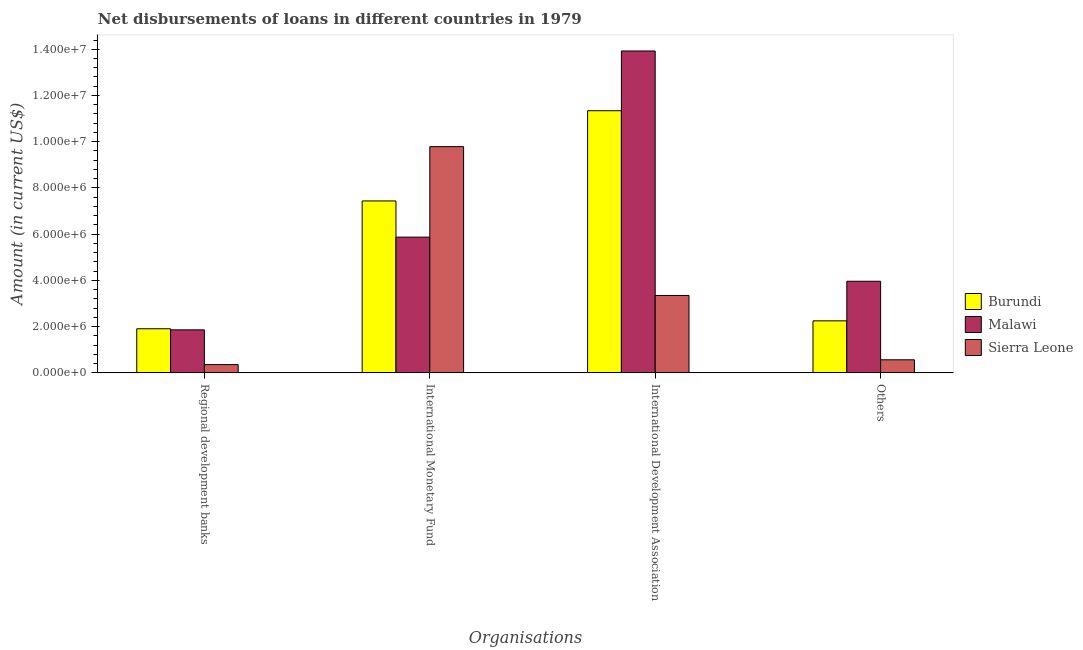How many groups of bars are there?
Provide a short and direct response. 4. What is the label of the 4th group of bars from the left?
Ensure brevity in your answer.  Others. What is the amount of loan disimbursed by regional development banks in Sierra Leone?
Your response must be concise. 3.57e+05. Across all countries, what is the maximum amount of loan disimbursed by international monetary fund?
Ensure brevity in your answer.  9.79e+06. Across all countries, what is the minimum amount of loan disimbursed by regional development banks?
Make the answer very short. 3.57e+05. In which country was the amount of loan disimbursed by regional development banks maximum?
Provide a short and direct response. Burundi. In which country was the amount of loan disimbursed by international monetary fund minimum?
Provide a succinct answer. Malawi. What is the total amount of loan disimbursed by other organisations in the graph?
Provide a short and direct response. 6.78e+06. What is the difference between the amount of loan disimbursed by regional development banks in Burundi and that in Sierra Leone?
Your response must be concise. 1.55e+06. What is the difference between the amount of loan disimbursed by international development association in Burundi and the amount of loan disimbursed by regional development banks in Malawi?
Offer a terse response. 9.48e+06. What is the average amount of loan disimbursed by other organisations per country?
Keep it short and to the point. 2.26e+06. What is the difference between the amount of loan disimbursed by international development association and amount of loan disimbursed by international monetary fund in Sierra Leone?
Offer a terse response. -6.44e+06. In how many countries, is the amount of loan disimbursed by regional development banks greater than 6400000 US$?
Ensure brevity in your answer.  0. What is the ratio of the amount of loan disimbursed by other organisations in Sierra Leone to that in Burundi?
Offer a very short reply. 0.25. What is the difference between the highest and the second highest amount of loan disimbursed by regional development banks?
Make the answer very short. 4.70e+04. What is the difference between the highest and the lowest amount of loan disimbursed by international development association?
Offer a very short reply. 1.06e+07. Is it the case that in every country, the sum of the amount of loan disimbursed by international monetary fund and amount of loan disimbursed by international development association is greater than the sum of amount of loan disimbursed by other organisations and amount of loan disimbursed by regional development banks?
Your answer should be very brief. Yes. What does the 3rd bar from the left in Others represents?
Provide a short and direct response. Sierra Leone. What does the 1st bar from the right in Others represents?
Offer a terse response. Sierra Leone. Is it the case that in every country, the sum of the amount of loan disimbursed by regional development banks and amount of loan disimbursed by international monetary fund is greater than the amount of loan disimbursed by international development association?
Keep it short and to the point. No. How many bars are there?
Ensure brevity in your answer.  12. Are all the bars in the graph horizontal?
Keep it short and to the point. No. How many countries are there in the graph?
Make the answer very short. 3. What is the difference between two consecutive major ticks on the Y-axis?
Your answer should be compact. 2.00e+06. Does the graph contain any zero values?
Offer a very short reply. No. Does the graph contain grids?
Offer a terse response. No. How many legend labels are there?
Give a very brief answer. 3. What is the title of the graph?
Your answer should be compact. Net disbursements of loans in different countries in 1979. Does "Bahrain" appear as one of the legend labels in the graph?
Provide a succinct answer. No. What is the label or title of the X-axis?
Your answer should be compact. Organisations. What is the Amount (in current US$) in Burundi in Regional development banks?
Your answer should be compact. 1.91e+06. What is the Amount (in current US$) in Malawi in Regional development banks?
Give a very brief answer. 1.86e+06. What is the Amount (in current US$) of Sierra Leone in Regional development banks?
Your answer should be very brief. 3.57e+05. What is the Amount (in current US$) in Burundi in International Monetary Fund?
Your answer should be very brief. 7.44e+06. What is the Amount (in current US$) of Malawi in International Monetary Fund?
Provide a succinct answer. 5.87e+06. What is the Amount (in current US$) of Sierra Leone in International Monetary Fund?
Keep it short and to the point. 9.79e+06. What is the Amount (in current US$) of Burundi in International Development Association?
Provide a short and direct response. 1.13e+07. What is the Amount (in current US$) in Malawi in International Development Association?
Make the answer very short. 1.39e+07. What is the Amount (in current US$) of Sierra Leone in International Development Association?
Ensure brevity in your answer.  3.35e+06. What is the Amount (in current US$) in Burundi in Others?
Give a very brief answer. 2.25e+06. What is the Amount (in current US$) in Malawi in Others?
Make the answer very short. 3.96e+06. What is the Amount (in current US$) of Sierra Leone in Others?
Provide a succinct answer. 5.66e+05. Across all Organisations, what is the maximum Amount (in current US$) in Burundi?
Provide a succinct answer. 1.13e+07. Across all Organisations, what is the maximum Amount (in current US$) in Malawi?
Your answer should be compact. 1.39e+07. Across all Organisations, what is the maximum Amount (in current US$) in Sierra Leone?
Make the answer very short. 9.79e+06. Across all Organisations, what is the minimum Amount (in current US$) of Burundi?
Give a very brief answer. 1.91e+06. Across all Organisations, what is the minimum Amount (in current US$) in Malawi?
Provide a succinct answer. 1.86e+06. Across all Organisations, what is the minimum Amount (in current US$) in Sierra Leone?
Ensure brevity in your answer.  3.57e+05. What is the total Amount (in current US$) in Burundi in the graph?
Keep it short and to the point. 2.29e+07. What is the total Amount (in current US$) of Malawi in the graph?
Keep it short and to the point. 2.56e+07. What is the total Amount (in current US$) in Sierra Leone in the graph?
Offer a terse response. 1.41e+07. What is the difference between the Amount (in current US$) of Burundi in Regional development banks and that in International Monetary Fund?
Offer a terse response. -5.53e+06. What is the difference between the Amount (in current US$) of Malawi in Regional development banks and that in International Monetary Fund?
Make the answer very short. -4.01e+06. What is the difference between the Amount (in current US$) in Sierra Leone in Regional development banks and that in International Monetary Fund?
Your response must be concise. -9.43e+06. What is the difference between the Amount (in current US$) in Burundi in Regional development banks and that in International Development Association?
Your answer should be compact. -9.43e+06. What is the difference between the Amount (in current US$) of Malawi in Regional development banks and that in International Development Association?
Your answer should be very brief. -1.21e+07. What is the difference between the Amount (in current US$) in Sierra Leone in Regional development banks and that in International Development Association?
Make the answer very short. -2.99e+06. What is the difference between the Amount (in current US$) in Burundi in Regional development banks and that in Others?
Provide a succinct answer. -3.42e+05. What is the difference between the Amount (in current US$) in Malawi in Regional development banks and that in Others?
Offer a terse response. -2.10e+06. What is the difference between the Amount (in current US$) in Sierra Leone in Regional development banks and that in Others?
Ensure brevity in your answer.  -2.09e+05. What is the difference between the Amount (in current US$) in Burundi in International Monetary Fund and that in International Development Association?
Provide a short and direct response. -3.90e+06. What is the difference between the Amount (in current US$) of Malawi in International Monetary Fund and that in International Development Association?
Keep it short and to the point. -8.05e+06. What is the difference between the Amount (in current US$) of Sierra Leone in International Monetary Fund and that in International Development Association?
Your response must be concise. 6.44e+06. What is the difference between the Amount (in current US$) in Burundi in International Monetary Fund and that in Others?
Offer a very short reply. 5.19e+06. What is the difference between the Amount (in current US$) in Malawi in International Monetary Fund and that in Others?
Offer a very short reply. 1.91e+06. What is the difference between the Amount (in current US$) in Sierra Leone in International Monetary Fund and that in Others?
Your answer should be very brief. 9.22e+06. What is the difference between the Amount (in current US$) in Burundi in International Development Association and that in Others?
Ensure brevity in your answer.  9.09e+06. What is the difference between the Amount (in current US$) of Malawi in International Development Association and that in Others?
Make the answer very short. 9.96e+06. What is the difference between the Amount (in current US$) in Sierra Leone in International Development Association and that in Others?
Your response must be concise. 2.78e+06. What is the difference between the Amount (in current US$) in Burundi in Regional development banks and the Amount (in current US$) in Malawi in International Monetary Fund?
Your answer should be very brief. -3.96e+06. What is the difference between the Amount (in current US$) in Burundi in Regional development banks and the Amount (in current US$) in Sierra Leone in International Monetary Fund?
Make the answer very short. -7.88e+06. What is the difference between the Amount (in current US$) of Malawi in Regional development banks and the Amount (in current US$) of Sierra Leone in International Monetary Fund?
Offer a terse response. -7.93e+06. What is the difference between the Amount (in current US$) in Burundi in Regional development banks and the Amount (in current US$) in Malawi in International Development Association?
Give a very brief answer. -1.20e+07. What is the difference between the Amount (in current US$) of Burundi in Regional development banks and the Amount (in current US$) of Sierra Leone in International Development Association?
Provide a short and direct response. -1.44e+06. What is the difference between the Amount (in current US$) in Malawi in Regional development banks and the Amount (in current US$) in Sierra Leone in International Development Association?
Provide a short and direct response. -1.49e+06. What is the difference between the Amount (in current US$) in Burundi in Regional development banks and the Amount (in current US$) in Malawi in Others?
Offer a terse response. -2.06e+06. What is the difference between the Amount (in current US$) in Burundi in Regional development banks and the Amount (in current US$) in Sierra Leone in Others?
Offer a very short reply. 1.34e+06. What is the difference between the Amount (in current US$) in Malawi in Regional development banks and the Amount (in current US$) in Sierra Leone in Others?
Give a very brief answer. 1.30e+06. What is the difference between the Amount (in current US$) in Burundi in International Monetary Fund and the Amount (in current US$) in Malawi in International Development Association?
Ensure brevity in your answer.  -6.49e+06. What is the difference between the Amount (in current US$) of Burundi in International Monetary Fund and the Amount (in current US$) of Sierra Leone in International Development Association?
Give a very brief answer. 4.09e+06. What is the difference between the Amount (in current US$) in Malawi in International Monetary Fund and the Amount (in current US$) in Sierra Leone in International Development Association?
Your answer should be compact. 2.52e+06. What is the difference between the Amount (in current US$) of Burundi in International Monetary Fund and the Amount (in current US$) of Malawi in Others?
Your answer should be compact. 3.48e+06. What is the difference between the Amount (in current US$) of Burundi in International Monetary Fund and the Amount (in current US$) of Sierra Leone in Others?
Make the answer very short. 6.87e+06. What is the difference between the Amount (in current US$) in Malawi in International Monetary Fund and the Amount (in current US$) in Sierra Leone in Others?
Make the answer very short. 5.31e+06. What is the difference between the Amount (in current US$) in Burundi in International Development Association and the Amount (in current US$) in Malawi in Others?
Your answer should be very brief. 7.38e+06. What is the difference between the Amount (in current US$) of Burundi in International Development Association and the Amount (in current US$) of Sierra Leone in Others?
Your answer should be very brief. 1.08e+07. What is the difference between the Amount (in current US$) in Malawi in International Development Association and the Amount (in current US$) in Sierra Leone in Others?
Offer a terse response. 1.34e+07. What is the average Amount (in current US$) of Burundi per Organisations?
Ensure brevity in your answer.  5.73e+06. What is the average Amount (in current US$) in Malawi per Organisations?
Your answer should be compact. 6.41e+06. What is the average Amount (in current US$) of Sierra Leone per Organisations?
Provide a succinct answer. 3.51e+06. What is the difference between the Amount (in current US$) of Burundi and Amount (in current US$) of Malawi in Regional development banks?
Provide a succinct answer. 4.70e+04. What is the difference between the Amount (in current US$) of Burundi and Amount (in current US$) of Sierra Leone in Regional development banks?
Offer a very short reply. 1.55e+06. What is the difference between the Amount (in current US$) in Malawi and Amount (in current US$) in Sierra Leone in Regional development banks?
Provide a short and direct response. 1.50e+06. What is the difference between the Amount (in current US$) of Burundi and Amount (in current US$) of Malawi in International Monetary Fund?
Keep it short and to the point. 1.57e+06. What is the difference between the Amount (in current US$) of Burundi and Amount (in current US$) of Sierra Leone in International Monetary Fund?
Your answer should be very brief. -2.35e+06. What is the difference between the Amount (in current US$) of Malawi and Amount (in current US$) of Sierra Leone in International Monetary Fund?
Your answer should be very brief. -3.92e+06. What is the difference between the Amount (in current US$) of Burundi and Amount (in current US$) of Malawi in International Development Association?
Ensure brevity in your answer.  -2.58e+06. What is the difference between the Amount (in current US$) in Burundi and Amount (in current US$) in Sierra Leone in International Development Association?
Make the answer very short. 7.99e+06. What is the difference between the Amount (in current US$) in Malawi and Amount (in current US$) in Sierra Leone in International Development Association?
Provide a short and direct response. 1.06e+07. What is the difference between the Amount (in current US$) of Burundi and Amount (in current US$) of Malawi in Others?
Give a very brief answer. -1.71e+06. What is the difference between the Amount (in current US$) in Burundi and Amount (in current US$) in Sierra Leone in Others?
Provide a succinct answer. 1.68e+06. What is the difference between the Amount (in current US$) of Malawi and Amount (in current US$) of Sierra Leone in Others?
Offer a very short reply. 3.40e+06. What is the ratio of the Amount (in current US$) of Burundi in Regional development banks to that in International Monetary Fund?
Ensure brevity in your answer.  0.26. What is the ratio of the Amount (in current US$) in Malawi in Regional development banks to that in International Monetary Fund?
Give a very brief answer. 0.32. What is the ratio of the Amount (in current US$) in Sierra Leone in Regional development banks to that in International Monetary Fund?
Provide a short and direct response. 0.04. What is the ratio of the Amount (in current US$) of Burundi in Regional development banks to that in International Development Association?
Offer a terse response. 0.17. What is the ratio of the Amount (in current US$) in Malawi in Regional development banks to that in International Development Association?
Offer a terse response. 0.13. What is the ratio of the Amount (in current US$) of Sierra Leone in Regional development banks to that in International Development Association?
Ensure brevity in your answer.  0.11. What is the ratio of the Amount (in current US$) in Burundi in Regional development banks to that in Others?
Ensure brevity in your answer.  0.85. What is the ratio of the Amount (in current US$) in Malawi in Regional development banks to that in Others?
Give a very brief answer. 0.47. What is the ratio of the Amount (in current US$) in Sierra Leone in Regional development banks to that in Others?
Provide a short and direct response. 0.63. What is the ratio of the Amount (in current US$) of Burundi in International Monetary Fund to that in International Development Association?
Give a very brief answer. 0.66. What is the ratio of the Amount (in current US$) of Malawi in International Monetary Fund to that in International Development Association?
Your answer should be very brief. 0.42. What is the ratio of the Amount (in current US$) in Sierra Leone in International Monetary Fund to that in International Development Association?
Provide a short and direct response. 2.92. What is the ratio of the Amount (in current US$) in Burundi in International Monetary Fund to that in Others?
Offer a very short reply. 3.31. What is the ratio of the Amount (in current US$) of Malawi in International Monetary Fund to that in Others?
Offer a very short reply. 1.48. What is the ratio of the Amount (in current US$) of Sierra Leone in International Monetary Fund to that in Others?
Provide a short and direct response. 17.29. What is the ratio of the Amount (in current US$) in Burundi in International Development Association to that in Others?
Offer a terse response. 5.04. What is the ratio of the Amount (in current US$) of Malawi in International Development Association to that in Others?
Keep it short and to the point. 3.51. What is the ratio of the Amount (in current US$) in Sierra Leone in International Development Association to that in Others?
Ensure brevity in your answer.  5.92. What is the difference between the highest and the second highest Amount (in current US$) in Burundi?
Ensure brevity in your answer.  3.90e+06. What is the difference between the highest and the second highest Amount (in current US$) in Malawi?
Give a very brief answer. 8.05e+06. What is the difference between the highest and the second highest Amount (in current US$) of Sierra Leone?
Make the answer very short. 6.44e+06. What is the difference between the highest and the lowest Amount (in current US$) in Burundi?
Provide a succinct answer. 9.43e+06. What is the difference between the highest and the lowest Amount (in current US$) of Malawi?
Your answer should be compact. 1.21e+07. What is the difference between the highest and the lowest Amount (in current US$) of Sierra Leone?
Make the answer very short. 9.43e+06. 